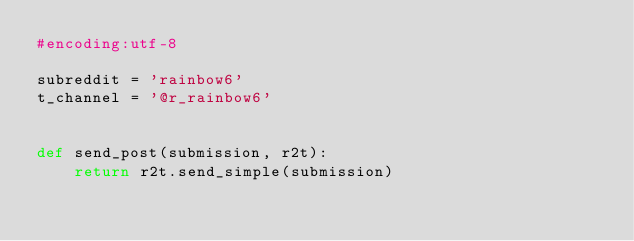Convert code to text. <code><loc_0><loc_0><loc_500><loc_500><_Python_>#encoding:utf-8

subreddit = 'rainbow6'
t_channel = '@r_rainbow6'


def send_post(submission, r2t):
    return r2t.send_simple(submission)
</code> 